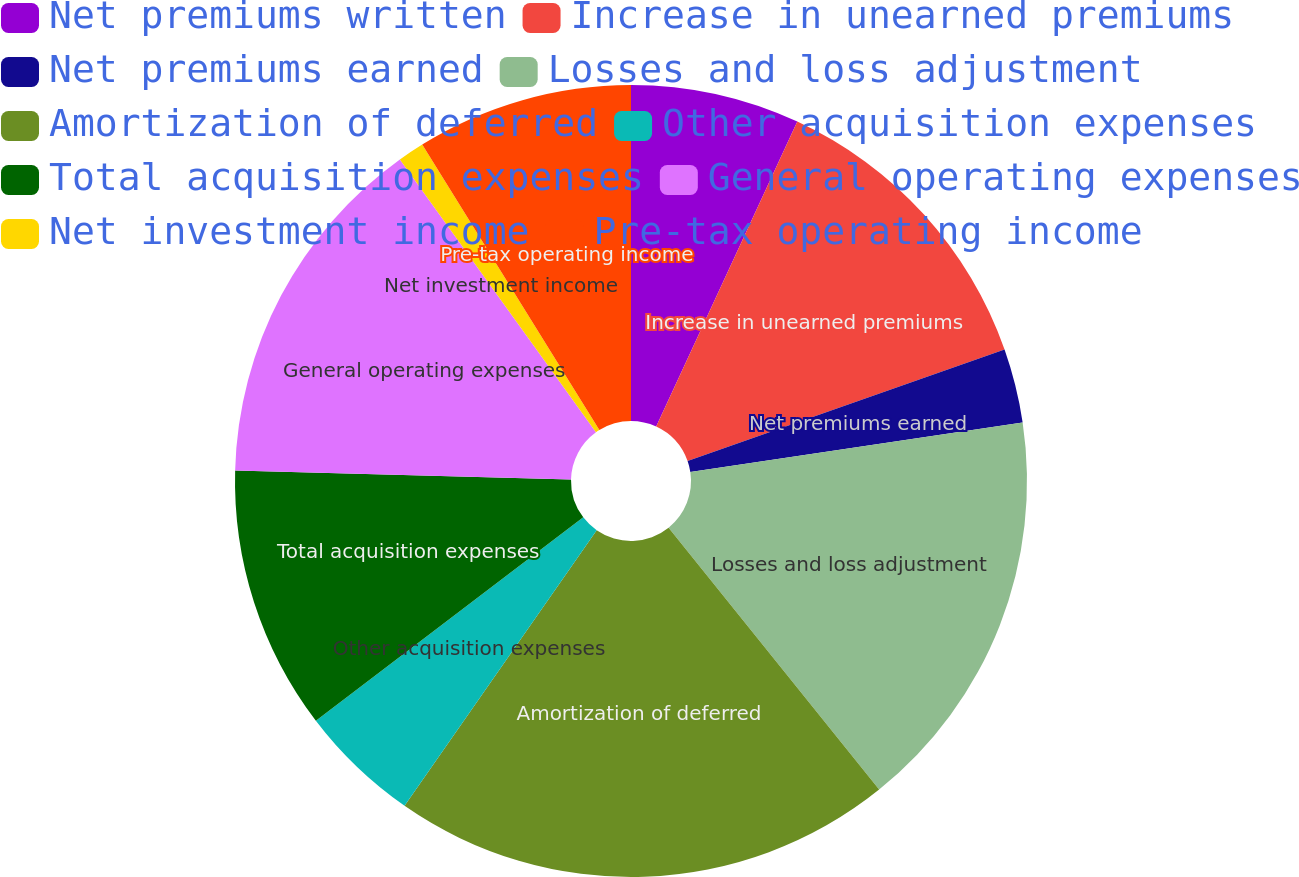<chart> <loc_0><loc_0><loc_500><loc_500><pie_chart><fcel>Net premiums written<fcel>Increase in unearned premiums<fcel>Net premiums earned<fcel>Losses and loss adjustment<fcel>Amortization of deferred<fcel>Other acquisition expenses<fcel>Total acquisition expenses<fcel>General operating expenses<fcel>Net investment income<fcel>Pre-tax operating income<nl><fcel>6.9%<fcel>12.72%<fcel>3.02%<fcel>16.59%<fcel>20.47%<fcel>4.96%<fcel>10.78%<fcel>14.66%<fcel>1.08%<fcel>8.84%<nl></chart> 